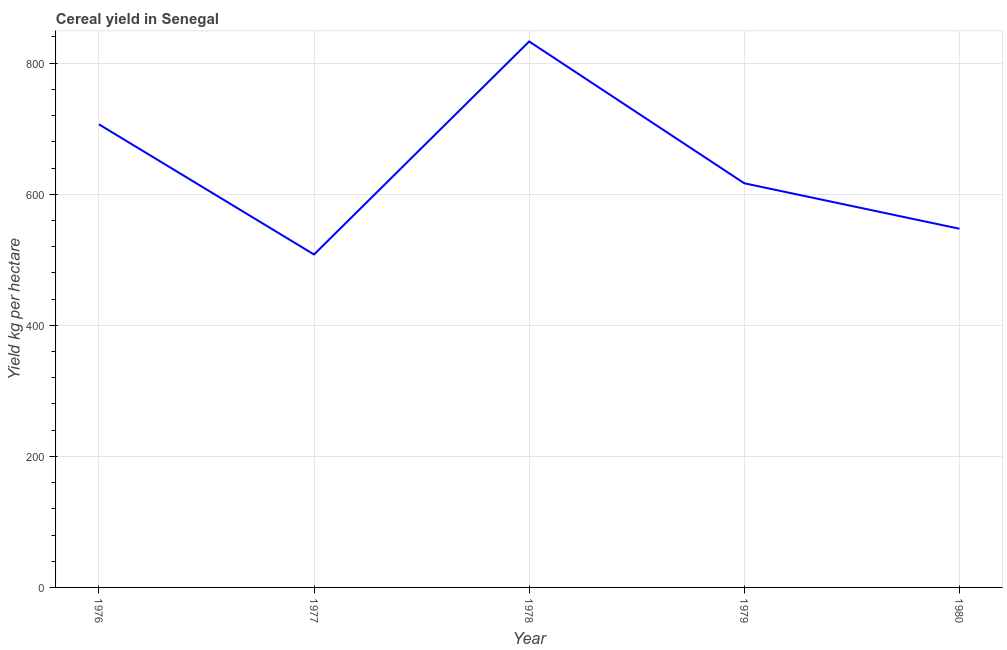What is the cereal yield in 1980?
Your answer should be very brief. 547.39. Across all years, what is the maximum cereal yield?
Offer a terse response. 833.17. Across all years, what is the minimum cereal yield?
Make the answer very short. 508.08. In which year was the cereal yield maximum?
Offer a very short reply. 1978. What is the sum of the cereal yield?
Ensure brevity in your answer.  3212.15. What is the difference between the cereal yield in 1976 and 1979?
Give a very brief answer. 90.01. What is the average cereal yield per year?
Provide a short and direct response. 642.43. What is the median cereal yield?
Give a very brief answer. 616.75. In how many years, is the cereal yield greater than 640 kg per hectare?
Provide a short and direct response. 2. Do a majority of the years between 1979 and 1980 (inclusive) have cereal yield greater than 280 kg per hectare?
Provide a succinct answer. Yes. What is the ratio of the cereal yield in 1976 to that in 1979?
Offer a terse response. 1.15. Is the cereal yield in 1979 less than that in 1980?
Your answer should be compact. No. Is the difference between the cereal yield in 1976 and 1978 greater than the difference between any two years?
Your answer should be compact. No. What is the difference between the highest and the second highest cereal yield?
Keep it short and to the point. 126.4. What is the difference between the highest and the lowest cereal yield?
Make the answer very short. 325.08. Does the cereal yield monotonically increase over the years?
Give a very brief answer. No. Are the values on the major ticks of Y-axis written in scientific E-notation?
Offer a terse response. No. Does the graph contain grids?
Provide a short and direct response. Yes. What is the title of the graph?
Give a very brief answer. Cereal yield in Senegal. What is the label or title of the Y-axis?
Provide a short and direct response. Yield kg per hectare. What is the Yield kg per hectare in 1976?
Ensure brevity in your answer.  706.76. What is the Yield kg per hectare in 1977?
Offer a very short reply. 508.08. What is the Yield kg per hectare in 1978?
Offer a very short reply. 833.17. What is the Yield kg per hectare of 1979?
Your answer should be compact. 616.75. What is the Yield kg per hectare in 1980?
Offer a very short reply. 547.39. What is the difference between the Yield kg per hectare in 1976 and 1977?
Your answer should be compact. 198.68. What is the difference between the Yield kg per hectare in 1976 and 1978?
Provide a short and direct response. -126.4. What is the difference between the Yield kg per hectare in 1976 and 1979?
Your response must be concise. 90.01. What is the difference between the Yield kg per hectare in 1976 and 1980?
Ensure brevity in your answer.  159.38. What is the difference between the Yield kg per hectare in 1977 and 1978?
Provide a short and direct response. -325.08. What is the difference between the Yield kg per hectare in 1977 and 1979?
Your response must be concise. -108.67. What is the difference between the Yield kg per hectare in 1977 and 1980?
Offer a terse response. -39.31. What is the difference between the Yield kg per hectare in 1978 and 1979?
Your answer should be very brief. 216.41. What is the difference between the Yield kg per hectare in 1978 and 1980?
Your response must be concise. 285.78. What is the difference between the Yield kg per hectare in 1979 and 1980?
Your answer should be very brief. 69.36. What is the ratio of the Yield kg per hectare in 1976 to that in 1977?
Provide a short and direct response. 1.39. What is the ratio of the Yield kg per hectare in 1976 to that in 1978?
Keep it short and to the point. 0.85. What is the ratio of the Yield kg per hectare in 1976 to that in 1979?
Provide a short and direct response. 1.15. What is the ratio of the Yield kg per hectare in 1976 to that in 1980?
Offer a very short reply. 1.29. What is the ratio of the Yield kg per hectare in 1977 to that in 1978?
Make the answer very short. 0.61. What is the ratio of the Yield kg per hectare in 1977 to that in 1979?
Provide a succinct answer. 0.82. What is the ratio of the Yield kg per hectare in 1977 to that in 1980?
Your answer should be compact. 0.93. What is the ratio of the Yield kg per hectare in 1978 to that in 1979?
Your response must be concise. 1.35. What is the ratio of the Yield kg per hectare in 1978 to that in 1980?
Make the answer very short. 1.52. What is the ratio of the Yield kg per hectare in 1979 to that in 1980?
Offer a very short reply. 1.13. 